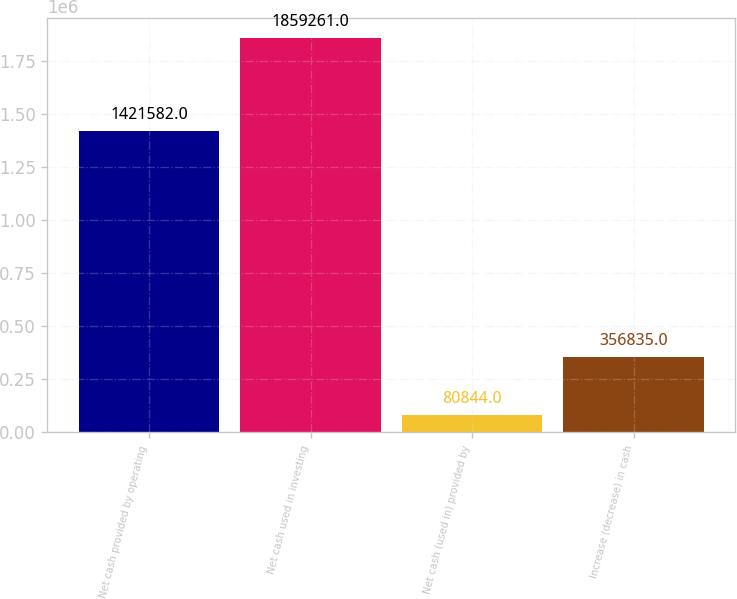Convert chart. <chart><loc_0><loc_0><loc_500><loc_500><bar_chart><fcel>Net cash provided by operating<fcel>Net cash used in investing<fcel>Net cash (used in) provided by<fcel>Increase (decrease) in cash<nl><fcel>1.42158e+06<fcel>1.85926e+06<fcel>80844<fcel>356835<nl></chart> 